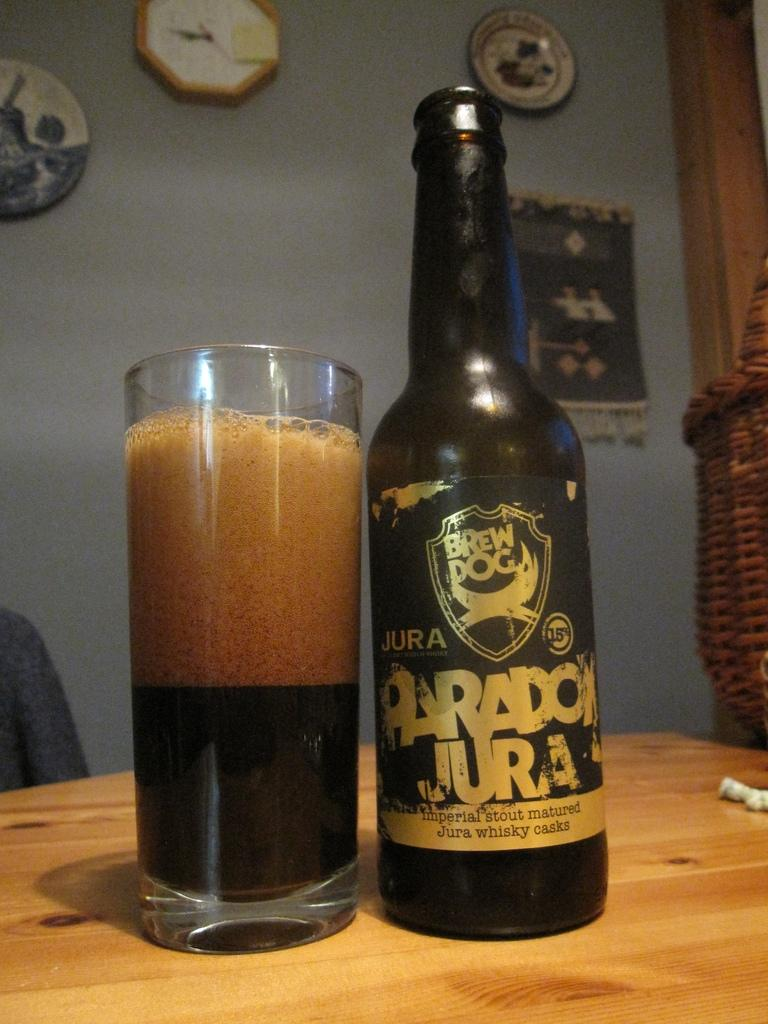<image>
Share a concise interpretation of the image provided. Glass and bottle of Paradon Jura by Brew Dog sitting on table 